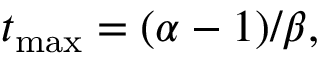Convert formula to latex. <formula><loc_0><loc_0><loc_500><loc_500>t _ { \max } = ( \alpha - 1 ) / \beta ,</formula> 